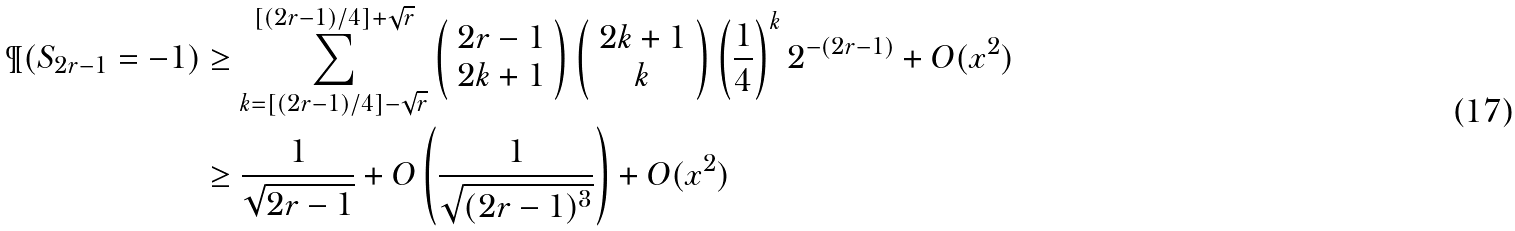Convert formula to latex. <formula><loc_0><loc_0><loc_500><loc_500>\P ( S _ { 2 r - 1 } = - 1 ) & \geq \sum _ { k = [ ( 2 r - 1 ) / 4 ] - \sqrt { r } } ^ { [ ( 2 r - 1 ) / 4 ] + \sqrt { r } } \left ( \begin{array} { c } 2 r - 1 \\ 2 k + 1 \end{array} \right ) \left ( \begin{array} { c } 2 k + 1 \\ k \end{array} \right ) \left ( \frac { 1 } { 4 } \right ) ^ { k } 2 ^ { - ( 2 r - 1 ) } + O ( x ^ { 2 } ) \\ & \geq \frac { 1 } { \sqrt { 2 r - 1 } } + O \left ( \frac { 1 } { \sqrt { ( 2 r - 1 ) ^ { 3 } } } \right ) + O ( x ^ { 2 } )</formula> 